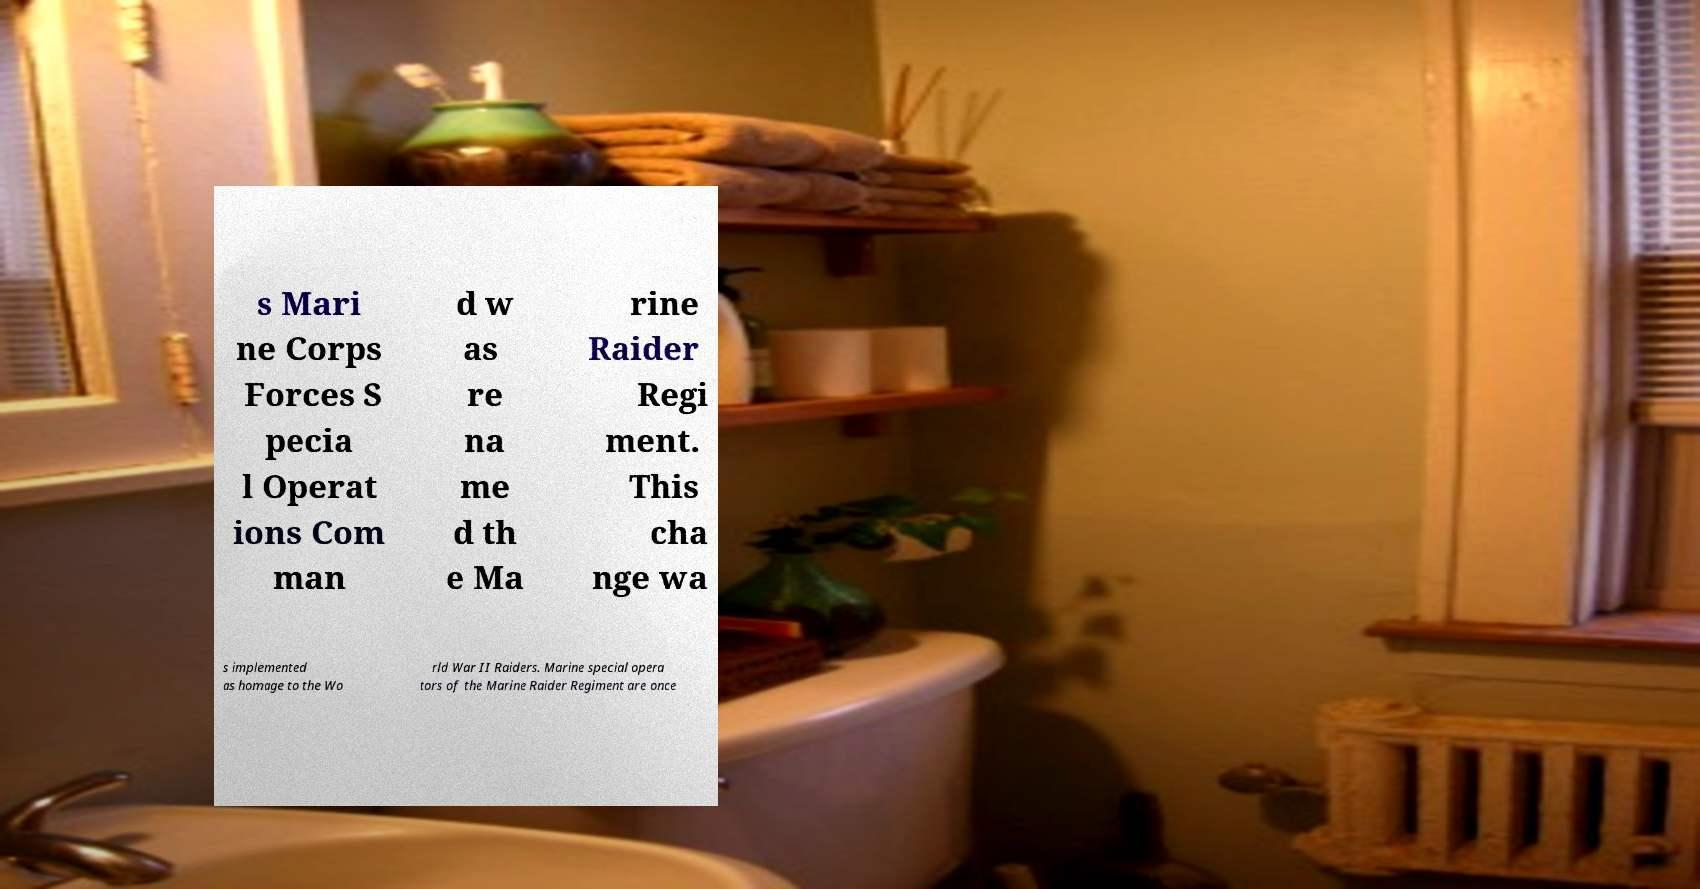What messages or text are displayed in this image? I need them in a readable, typed format. s Mari ne Corps Forces S pecia l Operat ions Com man d w as re na me d th e Ma rine Raider Regi ment. This cha nge wa s implemented as homage to the Wo rld War II Raiders. Marine special opera tors of the Marine Raider Regiment are once 